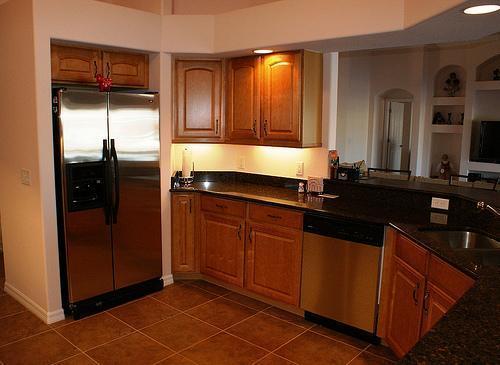How many lights are shown on?
Give a very brief answer. 2. How many cabinet doors are visible?
Give a very brief answer. 10. How many doors does the refrigerator have?
Give a very brief answer. 2. 